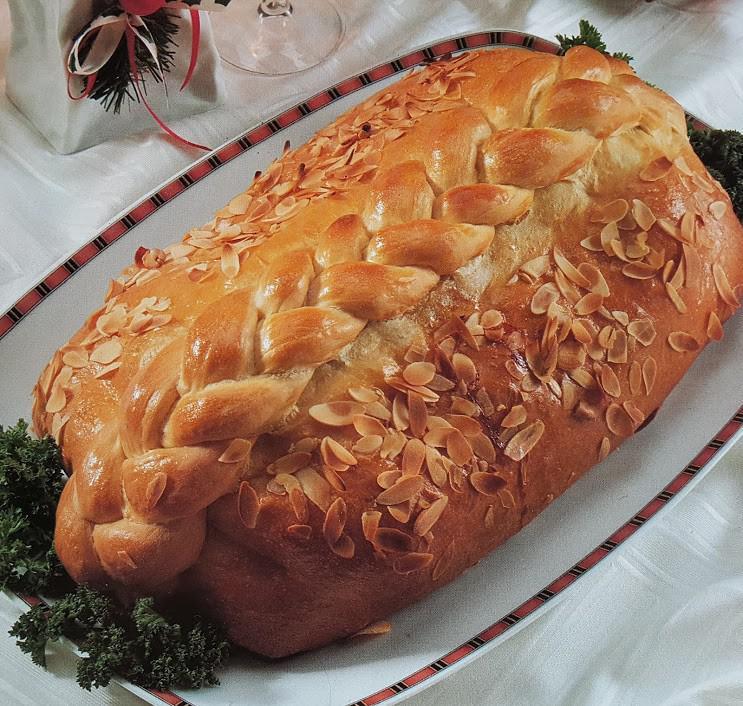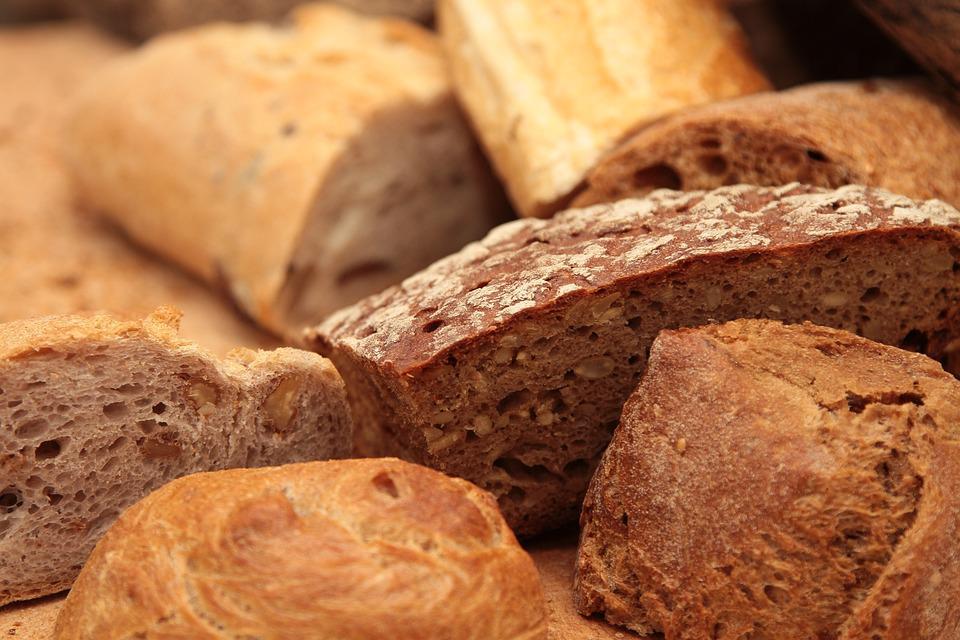The first image is the image on the left, the second image is the image on the right. For the images displayed, is the sentence "One of the loaves is placed in an oval dish." factually correct? Answer yes or no. Yes. The first image is the image on the left, the second image is the image on the right. Given the left and right images, does the statement "None of the bread is cut in at least one of the images." hold true? Answer yes or no. Yes. 